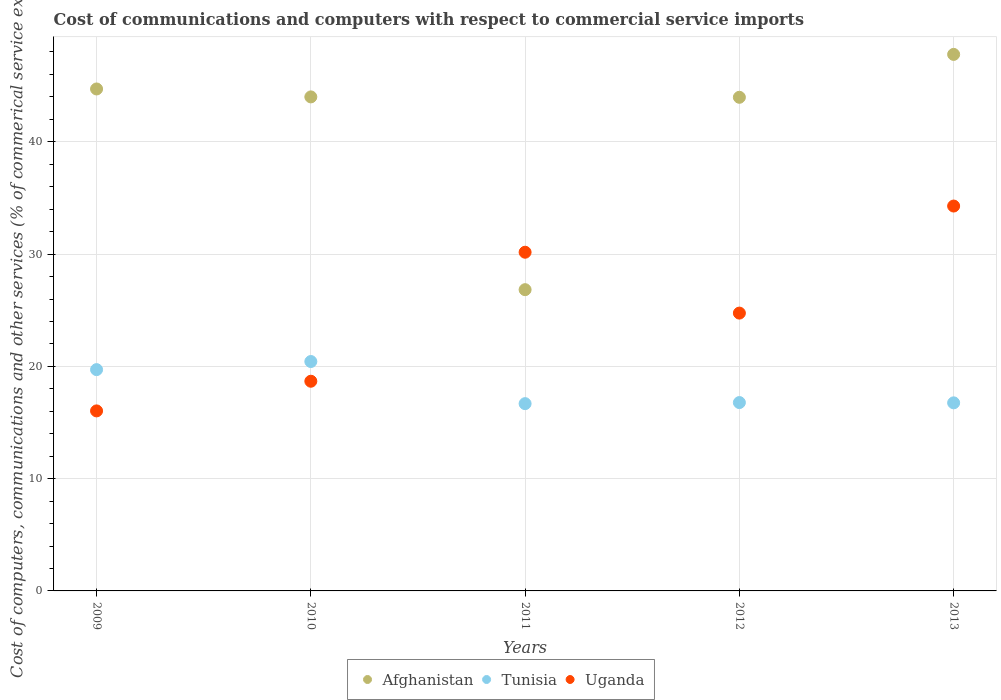Is the number of dotlines equal to the number of legend labels?
Ensure brevity in your answer.  Yes. What is the cost of communications and computers in Uganda in 2013?
Offer a terse response. 34.28. Across all years, what is the maximum cost of communications and computers in Uganda?
Give a very brief answer. 34.28. Across all years, what is the minimum cost of communications and computers in Uganda?
Keep it short and to the point. 16.03. In which year was the cost of communications and computers in Afghanistan maximum?
Ensure brevity in your answer.  2013. In which year was the cost of communications and computers in Tunisia minimum?
Give a very brief answer. 2011. What is the total cost of communications and computers in Uganda in the graph?
Give a very brief answer. 123.9. What is the difference between the cost of communications and computers in Tunisia in 2010 and that in 2011?
Your answer should be compact. 3.75. What is the difference between the cost of communications and computers in Tunisia in 2011 and the cost of communications and computers in Afghanistan in 2013?
Your answer should be very brief. -31.11. What is the average cost of communications and computers in Tunisia per year?
Offer a very short reply. 18.07. In the year 2012, what is the difference between the cost of communications and computers in Tunisia and cost of communications and computers in Afghanistan?
Give a very brief answer. -27.19. What is the ratio of the cost of communications and computers in Afghanistan in 2010 to that in 2012?
Provide a short and direct response. 1. What is the difference between the highest and the second highest cost of communications and computers in Tunisia?
Your answer should be very brief. 0.72. What is the difference between the highest and the lowest cost of communications and computers in Afghanistan?
Ensure brevity in your answer.  20.95. Is the sum of the cost of communications and computers in Uganda in 2009 and 2012 greater than the maximum cost of communications and computers in Afghanistan across all years?
Give a very brief answer. No. Does the cost of communications and computers in Tunisia monotonically increase over the years?
Provide a short and direct response. No. Is the cost of communications and computers in Uganda strictly greater than the cost of communications and computers in Afghanistan over the years?
Keep it short and to the point. No. How many dotlines are there?
Ensure brevity in your answer.  3. How many years are there in the graph?
Offer a very short reply. 5. Does the graph contain grids?
Make the answer very short. Yes. What is the title of the graph?
Keep it short and to the point. Cost of communications and computers with respect to commercial service imports. Does "Montenegro" appear as one of the legend labels in the graph?
Ensure brevity in your answer.  No. What is the label or title of the X-axis?
Your answer should be very brief. Years. What is the label or title of the Y-axis?
Offer a very short reply. Cost of computers, communications and other services (% of commerical service exports). What is the Cost of computers, communications and other services (% of commerical service exports) in Afghanistan in 2009?
Provide a succinct answer. 44.71. What is the Cost of computers, communications and other services (% of commerical service exports) in Tunisia in 2009?
Offer a very short reply. 19.71. What is the Cost of computers, communications and other services (% of commerical service exports) in Uganda in 2009?
Your answer should be very brief. 16.03. What is the Cost of computers, communications and other services (% of commerical service exports) of Afghanistan in 2010?
Make the answer very short. 44. What is the Cost of computers, communications and other services (% of commerical service exports) of Tunisia in 2010?
Give a very brief answer. 20.43. What is the Cost of computers, communications and other services (% of commerical service exports) in Uganda in 2010?
Keep it short and to the point. 18.68. What is the Cost of computers, communications and other services (% of commerical service exports) of Afghanistan in 2011?
Make the answer very short. 26.83. What is the Cost of computers, communications and other services (% of commerical service exports) of Tunisia in 2011?
Offer a very short reply. 16.68. What is the Cost of computers, communications and other services (% of commerical service exports) of Uganda in 2011?
Offer a very short reply. 30.17. What is the Cost of computers, communications and other services (% of commerical service exports) in Afghanistan in 2012?
Make the answer very short. 43.97. What is the Cost of computers, communications and other services (% of commerical service exports) in Tunisia in 2012?
Keep it short and to the point. 16.78. What is the Cost of computers, communications and other services (% of commerical service exports) in Uganda in 2012?
Ensure brevity in your answer.  24.74. What is the Cost of computers, communications and other services (% of commerical service exports) of Afghanistan in 2013?
Your answer should be very brief. 47.79. What is the Cost of computers, communications and other services (% of commerical service exports) in Tunisia in 2013?
Offer a very short reply. 16.75. What is the Cost of computers, communications and other services (% of commerical service exports) in Uganda in 2013?
Provide a succinct answer. 34.28. Across all years, what is the maximum Cost of computers, communications and other services (% of commerical service exports) of Afghanistan?
Your answer should be compact. 47.79. Across all years, what is the maximum Cost of computers, communications and other services (% of commerical service exports) in Tunisia?
Your response must be concise. 20.43. Across all years, what is the maximum Cost of computers, communications and other services (% of commerical service exports) in Uganda?
Ensure brevity in your answer.  34.28. Across all years, what is the minimum Cost of computers, communications and other services (% of commerical service exports) in Afghanistan?
Make the answer very short. 26.83. Across all years, what is the minimum Cost of computers, communications and other services (% of commerical service exports) of Tunisia?
Your answer should be very brief. 16.68. Across all years, what is the minimum Cost of computers, communications and other services (% of commerical service exports) in Uganda?
Your answer should be very brief. 16.03. What is the total Cost of computers, communications and other services (% of commerical service exports) of Afghanistan in the graph?
Give a very brief answer. 207.29. What is the total Cost of computers, communications and other services (% of commerical service exports) in Tunisia in the graph?
Ensure brevity in your answer.  90.35. What is the total Cost of computers, communications and other services (% of commerical service exports) in Uganda in the graph?
Ensure brevity in your answer.  123.9. What is the difference between the Cost of computers, communications and other services (% of commerical service exports) in Afghanistan in 2009 and that in 2010?
Provide a short and direct response. 0.71. What is the difference between the Cost of computers, communications and other services (% of commerical service exports) of Tunisia in 2009 and that in 2010?
Your answer should be very brief. -0.72. What is the difference between the Cost of computers, communications and other services (% of commerical service exports) in Uganda in 2009 and that in 2010?
Offer a very short reply. -2.64. What is the difference between the Cost of computers, communications and other services (% of commerical service exports) of Afghanistan in 2009 and that in 2011?
Offer a terse response. 17.88. What is the difference between the Cost of computers, communications and other services (% of commerical service exports) of Tunisia in 2009 and that in 2011?
Your answer should be very brief. 3.03. What is the difference between the Cost of computers, communications and other services (% of commerical service exports) of Uganda in 2009 and that in 2011?
Provide a succinct answer. -14.13. What is the difference between the Cost of computers, communications and other services (% of commerical service exports) in Afghanistan in 2009 and that in 2012?
Offer a very short reply. 0.74. What is the difference between the Cost of computers, communications and other services (% of commerical service exports) in Tunisia in 2009 and that in 2012?
Make the answer very short. 2.93. What is the difference between the Cost of computers, communications and other services (% of commerical service exports) of Uganda in 2009 and that in 2012?
Provide a succinct answer. -8.71. What is the difference between the Cost of computers, communications and other services (% of commerical service exports) in Afghanistan in 2009 and that in 2013?
Your response must be concise. -3.08. What is the difference between the Cost of computers, communications and other services (% of commerical service exports) in Tunisia in 2009 and that in 2013?
Your response must be concise. 2.96. What is the difference between the Cost of computers, communications and other services (% of commerical service exports) of Uganda in 2009 and that in 2013?
Ensure brevity in your answer.  -18.25. What is the difference between the Cost of computers, communications and other services (% of commerical service exports) in Afghanistan in 2010 and that in 2011?
Your answer should be very brief. 17.17. What is the difference between the Cost of computers, communications and other services (% of commerical service exports) of Tunisia in 2010 and that in 2011?
Keep it short and to the point. 3.75. What is the difference between the Cost of computers, communications and other services (% of commerical service exports) of Uganda in 2010 and that in 2011?
Give a very brief answer. -11.49. What is the difference between the Cost of computers, communications and other services (% of commerical service exports) in Afghanistan in 2010 and that in 2012?
Provide a short and direct response. 0.03. What is the difference between the Cost of computers, communications and other services (% of commerical service exports) of Tunisia in 2010 and that in 2012?
Provide a short and direct response. 3.66. What is the difference between the Cost of computers, communications and other services (% of commerical service exports) in Uganda in 2010 and that in 2012?
Keep it short and to the point. -6.07. What is the difference between the Cost of computers, communications and other services (% of commerical service exports) in Afghanistan in 2010 and that in 2013?
Provide a short and direct response. -3.79. What is the difference between the Cost of computers, communications and other services (% of commerical service exports) of Tunisia in 2010 and that in 2013?
Your response must be concise. 3.68. What is the difference between the Cost of computers, communications and other services (% of commerical service exports) in Uganda in 2010 and that in 2013?
Provide a succinct answer. -15.6. What is the difference between the Cost of computers, communications and other services (% of commerical service exports) of Afghanistan in 2011 and that in 2012?
Your answer should be very brief. -17.13. What is the difference between the Cost of computers, communications and other services (% of commerical service exports) in Tunisia in 2011 and that in 2012?
Provide a succinct answer. -0.1. What is the difference between the Cost of computers, communications and other services (% of commerical service exports) in Uganda in 2011 and that in 2012?
Offer a very short reply. 5.42. What is the difference between the Cost of computers, communications and other services (% of commerical service exports) of Afghanistan in 2011 and that in 2013?
Offer a very short reply. -20.95. What is the difference between the Cost of computers, communications and other services (% of commerical service exports) in Tunisia in 2011 and that in 2013?
Offer a very short reply. -0.07. What is the difference between the Cost of computers, communications and other services (% of commerical service exports) of Uganda in 2011 and that in 2013?
Your answer should be compact. -4.11. What is the difference between the Cost of computers, communications and other services (% of commerical service exports) of Afghanistan in 2012 and that in 2013?
Your response must be concise. -3.82. What is the difference between the Cost of computers, communications and other services (% of commerical service exports) of Tunisia in 2012 and that in 2013?
Your answer should be very brief. 0.03. What is the difference between the Cost of computers, communications and other services (% of commerical service exports) in Uganda in 2012 and that in 2013?
Your answer should be very brief. -9.53. What is the difference between the Cost of computers, communications and other services (% of commerical service exports) of Afghanistan in 2009 and the Cost of computers, communications and other services (% of commerical service exports) of Tunisia in 2010?
Keep it short and to the point. 24.27. What is the difference between the Cost of computers, communications and other services (% of commerical service exports) of Afghanistan in 2009 and the Cost of computers, communications and other services (% of commerical service exports) of Uganda in 2010?
Make the answer very short. 26.03. What is the difference between the Cost of computers, communications and other services (% of commerical service exports) of Tunisia in 2009 and the Cost of computers, communications and other services (% of commerical service exports) of Uganda in 2010?
Ensure brevity in your answer.  1.03. What is the difference between the Cost of computers, communications and other services (% of commerical service exports) of Afghanistan in 2009 and the Cost of computers, communications and other services (% of commerical service exports) of Tunisia in 2011?
Provide a succinct answer. 28.03. What is the difference between the Cost of computers, communications and other services (% of commerical service exports) in Afghanistan in 2009 and the Cost of computers, communications and other services (% of commerical service exports) in Uganda in 2011?
Your answer should be very brief. 14.54. What is the difference between the Cost of computers, communications and other services (% of commerical service exports) of Tunisia in 2009 and the Cost of computers, communications and other services (% of commerical service exports) of Uganda in 2011?
Your answer should be very brief. -10.46. What is the difference between the Cost of computers, communications and other services (% of commerical service exports) in Afghanistan in 2009 and the Cost of computers, communications and other services (% of commerical service exports) in Tunisia in 2012?
Your response must be concise. 27.93. What is the difference between the Cost of computers, communications and other services (% of commerical service exports) of Afghanistan in 2009 and the Cost of computers, communications and other services (% of commerical service exports) of Uganda in 2012?
Ensure brevity in your answer.  19.96. What is the difference between the Cost of computers, communications and other services (% of commerical service exports) of Tunisia in 2009 and the Cost of computers, communications and other services (% of commerical service exports) of Uganda in 2012?
Your answer should be compact. -5.03. What is the difference between the Cost of computers, communications and other services (% of commerical service exports) of Afghanistan in 2009 and the Cost of computers, communications and other services (% of commerical service exports) of Tunisia in 2013?
Offer a terse response. 27.96. What is the difference between the Cost of computers, communications and other services (% of commerical service exports) of Afghanistan in 2009 and the Cost of computers, communications and other services (% of commerical service exports) of Uganda in 2013?
Offer a very short reply. 10.43. What is the difference between the Cost of computers, communications and other services (% of commerical service exports) in Tunisia in 2009 and the Cost of computers, communications and other services (% of commerical service exports) in Uganda in 2013?
Your answer should be compact. -14.57. What is the difference between the Cost of computers, communications and other services (% of commerical service exports) of Afghanistan in 2010 and the Cost of computers, communications and other services (% of commerical service exports) of Tunisia in 2011?
Your answer should be compact. 27.32. What is the difference between the Cost of computers, communications and other services (% of commerical service exports) in Afghanistan in 2010 and the Cost of computers, communications and other services (% of commerical service exports) in Uganda in 2011?
Ensure brevity in your answer.  13.83. What is the difference between the Cost of computers, communications and other services (% of commerical service exports) in Tunisia in 2010 and the Cost of computers, communications and other services (% of commerical service exports) in Uganda in 2011?
Provide a succinct answer. -9.73. What is the difference between the Cost of computers, communications and other services (% of commerical service exports) in Afghanistan in 2010 and the Cost of computers, communications and other services (% of commerical service exports) in Tunisia in 2012?
Provide a succinct answer. 27.22. What is the difference between the Cost of computers, communications and other services (% of commerical service exports) of Afghanistan in 2010 and the Cost of computers, communications and other services (% of commerical service exports) of Uganda in 2012?
Offer a very short reply. 19.26. What is the difference between the Cost of computers, communications and other services (% of commerical service exports) of Tunisia in 2010 and the Cost of computers, communications and other services (% of commerical service exports) of Uganda in 2012?
Offer a terse response. -4.31. What is the difference between the Cost of computers, communications and other services (% of commerical service exports) of Afghanistan in 2010 and the Cost of computers, communications and other services (% of commerical service exports) of Tunisia in 2013?
Offer a terse response. 27.25. What is the difference between the Cost of computers, communications and other services (% of commerical service exports) of Afghanistan in 2010 and the Cost of computers, communications and other services (% of commerical service exports) of Uganda in 2013?
Provide a succinct answer. 9.72. What is the difference between the Cost of computers, communications and other services (% of commerical service exports) of Tunisia in 2010 and the Cost of computers, communications and other services (% of commerical service exports) of Uganda in 2013?
Your response must be concise. -13.85. What is the difference between the Cost of computers, communications and other services (% of commerical service exports) in Afghanistan in 2011 and the Cost of computers, communications and other services (% of commerical service exports) in Tunisia in 2012?
Offer a very short reply. 10.05. What is the difference between the Cost of computers, communications and other services (% of commerical service exports) of Afghanistan in 2011 and the Cost of computers, communications and other services (% of commerical service exports) of Uganda in 2012?
Give a very brief answer. 2.09. What is the difference between the Cost of computers, communications and other services (% of commerical service exports) in Tunisia in 2011 and the Cost of computers, communications and other services (% of commerical service exports) in Uganda in 2012?
Your answer should be very brief. -8.06. What is the difference between the Cost of computers, communications and other services (% of commerical service exports) of Afghanistan in 2011 and the Cost of computers, communications and other services (% of commerical service exports) of Tunisia in 2013?
Keep it short and to the point. 10.08. What is the difference between the Cost of computers, communications and other services (% of commerical service exports) of Afghanistan in 2011 and the Cost of computers, communications and other services (% of commerical service exports) of Uganda in 2013?
Keep it short and to the point. -7.45. What is the difference between the Cost of computers, communications and other services (% of commerical service exports) of Tunisia in 2011 and the Cost of computers, communications and other services (% of commerical service exports) of Uganda in 2013?
Provide a succinct answer. -17.6. What is the difference between the Cost of computers, communications and other services (% of commerical service exports) in Afghanistan in 2012 and the Cost of computers, communications and other services (% of commerical service exports) in Tunisia in 2013?
Offer a terse response. 27.21. What is the difference between the Cost of computers, communications and other services (% of commerical service exports) in Afghanistan in 2012 and the Cost of computers, communications and other services (% of commerical service exports) in Uganda in 2013?
Make the answer very short. 9.69. What is the difference between the Cost of computers, communications and other services (% of commerical service exports) of Tunisia in 2012 and the Cost of computers, communications and other services (% of commerical service exports) of Uganda in 2013?
Provide a succinct answer. -17.5. What is the average Cost of computers, communications and other services (% of commerical service exports) in Afghanistan per year?
Provide a succinct answer. 41.46. What is the average Cost of computers, communications and other services (% of commerical service exports) of Tunisia per year?
Give a very brief answer. 18.07. What is the average Cost of computers, communications and other services (% of commerical service exports) in Uganda per year?
Provide a short and direct response. 24.78. In the year 2009, what is the difference between the Cost of computers, communications and other services (% of commerical service exports) of Afghanistan and Cost of computers, communications and other services (% of commerical service exports) of Tunisia?
Your response must be concise. 25. In the year 2009, what is the difference between the Cost of computers, communications and other services (% of commerical service exports) of Afghanistan and Cost of computers, communications and other services (% of commerical service exports) of Uganda?
Offer a terse response. 28.67. In the year 2009, what is the difference between the Cost of computers, communications and other services (% of commerical service exports) in Tunisia and Cost of computers, communications and other services (% of commerical service exports) in Uganda?
Your answer should be compact. 3.68. In the year 2010, what is the difference between the Cost of computers, communications and other services (% of commerical service exports) in Afghanistan and Cost of computers, communications and other services (% of commerical service exports) in Tunisia?
Your response must be concise. 23.57. In the year 2010, what is the difference between the Cost of computers, communications and other services (% of commerical service exports) in Afghanistan and Cost of computers, communications and other services (% of commerical service exports) in Uganda?
Offer a very short reply. 25.32. In the year 2010, what is the difference between the Cost of computers, communications and other services (% of commerical service exports) of Tunisia and Cost of computers, communications and other services (% of commerical service exports) of Uganda?
Your response must be concise. 1.76. In the year 2011, what is the difference between the Cost of computers, communications and other services (% of commerical service exports) in Afghanistan and Cost of computers, communications and other services (% of commerical service exports) in Tunisia?
Ensure brevity in your answer.  10.15. In the year 2011, what is the difference between the Cost of computers, communications and other services (% of commerical service exports) of Afghanistan and Cost of computers, communications and other services (% of commerical service exports) of Uganda?
Provide a succinct answer. -3.33. In the year 2011, what is the difference between the Cost of computers, communications and other services (% of commerical service exports) of Tunisia and Cost of computers, communications and other services (% of commerical service exports) of Uganda?
Your answer should be very brief. -13.49. In the year 2012, what is the difference between the Cost of computers, communications and other services (% of commerical service exports) of Afghanistan and Cost of computers, communications and other services (% of commerical service exports) of Tunisia?
Your answer should be compact. 27.19. In the year 2012, what is the difference between the Cost of computers, communications and other services (% of commerical service exports) in Afghanistan and Cost of computers, communications and other services (% of commerical service exports) in Uganda?
Make the answer very short. 19.22. In the year 2012, what is the difference between the Cost of computers, communications and other services (% of commerical service exports) in Tunisia and Cost of computers, communications and other services (% of commerical service exports) in Uganda?
Keep it short and to the point. -7.97. In the year 2013, what is the difference between the Cost of computers, communications and other services (% of commerical service exports) in Afghanistan and Cost of computers, communications and other services (% of commerical service exports) in Tunisia?
Give a very brief answer. 31.03. In the year 2013, what is the difference between the Cost of computers, communications and other services (% of commerical service exports) in Afghanistan and Cost of computers, communications and other services (% of commerical service exports) in Uganda?
Provide a short and direct response. 13.51. In the year 2013, what is the difference between the Cost of computers, communications and other services (% of commerical service exports) of Tunisia and Cost of computers, communications and other services (% of commerical service exports) of Uganda?
Offer a terse response. -17.53. What is the ratio of the Cost of computers, communications and other services (% of commerical service exports) of Afghanistan in 2009 to that in 2010?
Your answer should be very brief. 1.02. What is the ratio of the Cost of computers, communications and other services (% of commerical service exports) in Tunisia in 2009 to that in 2010?
Make the answer very short. 0.96. What is the ratio of the Cost of computers, communications and other services (% of commerical service exports) in Uganda in 2009 to that in 2010?
Your answer should be compact. 0.86. What is the ratio of the Cost of computers, communications and other services (% of commerical service exports) of Afghanistan in 2009 to that in 2011?
Your response must be concise. 1.67. What is the ratio of the Cost of computers, communications and other services (% of commerical service exports) of Tunisia in 2009 to that in 2011?
Provide a succinct answer. 1.18. What is the ratio of the Cost of computers, communications and other services (% of commerical service exports) in Uganda in 2009 to that in 2011?
Offer a very short reply. 0.53. What is the ratio of the Cost of computers, communications and other services (% of commerical service exports) in Afghanistan in 2009 to that in 2012?
Make the answer very short. 1.02. What is the ratio of the Cost of computers, communications and other services (% of commerical service exports) in Tunisia in 2009 to that in 2012?
Keep it short and to the point. 1.17. What is the ratio of the Cost of computers, communications and other services (% of commerical service exports) in Uganda in 2009 to that in 2012?
Make the answer very short. 0.65. What is the ratio of the Cost of computers, communications and other services (% of commerical service exports) of Afghanistan in 2009 to that in 2013?
Your answer should be compact. 0.94. What is the ratio of the Cost of computers, communications and other services (% of commerical service exports) of Tunisia in 2009 to that in 2013?
Make the answer very short. 1.18. What is the ratio of the Cost of computers, communications and other services (% of commerical service exports) in Uganda in 2009 to that in 2013?
Keep it short and to the point. 0.47. What is the ratio of the Cost of computers, communications and other services (% of commerical service exports) of Afghanistan in 2010 to that in 2011?
Your response must be concise. 1.64. What is the ratio of the Cost of computers, communications and other services (% of commerical service exports) in Tunisia in 2010 to that in 2011?
Ensure brevity in your answer.  1.22. What is the ratio of the Cost of computers, communications and other services (% of commerical service exports) of Uganda in 2010 to that in 2011?
Make the answer very short. 0.62. What is the ratio of the Cost of computers, communications and other services (% of commerical service exports) in Tunisia in 2010 to that in 2012?
Offer a very short reply. 1.22. What is the ratio of the Cost of computers, communications and other services (% of commerical service exports) in Uganda in 2010 to that in 2012?
Offer a terse response. 0.75. What is the ratio of the Cost of computers, communications and other services (% of commerical service exports) of Afghanistan in 2010 to that in 2013?
Keep it short and to the point. 0.92. What is the ratio of the Cost of computers, communications and other services (% of commerical service exports) in Tunisia in 2010 to that in 2013?
Keep it short and to the point. 1.22. What is the ratio of the Cost of computers, communications and other services (% of commerical service exports) in Uganda in 2010 to that in 2013?
Provide a succinct answer. 0.54. What is the ratio of the Cost of computers, communications and other services (% of commerical service exports) of Afghanistan in 2011 to that in 2012?
Give a very brief answer. 0.61. What is the ratio of the Cost of computers, communications and other services (% of commerical service exports) in Uganda in 2011 to that in 2012?
Offer a terse response. 1.22. What is the ratio of the Cost of computers, communications and other services (% of commerical service exports) of Afghanistan in 2011 to that in 2013?
Your answer should be very brief. 0.56. What is the ratio of the Cost of computers, communications and other services (% of commerical service exports) in Uganda in 2011 to that in 2013?
Your response must be concise. 0.88. What is the ratio of the Cost of computers, communications and other services (% of commerical service exports) in Afghanistan in 2012 to that in 2013?
Make the answer very short. 0.92. What is the ratio of the Cost of computers, communications and other services (% of commerical service exports) of Uganda in 2012 to that in 2013?
Ensure brevity in your answer.  0.72. What is the difference between the highest and the second highest Cost of computers, communications and other services (% of commerical service exports) of Afghanistan?
Ensure brevity in your answer.  3.08. What is the difference between the highest and the second highest Cost of computers, communications and other services (% of commerical service exports) of Tunisia?
Ensure brevity in your answer.  0.72. What is the difference between the highest and the second highest Cost of computers, communications and other services (% of commerical service exports) of Uganda?
Your answer should be very brief. 4.11. What is the difference between the highest and the lowest Cost of computers, communications and other services (% of commerical service exports) of Afghanistan?
Provide a succinct answer. 20.95. What is the difference between the highest and the lowest Cost of computers, communications and other services (% of commerical service exports) of Tunisia?
Your response must be concise. 3.75. What is the difference between the highest and the lowest Cost of computers, communications and other services (% of commerical service exports) in Uganda?
Ensure brevity in your answer.  18.25. 